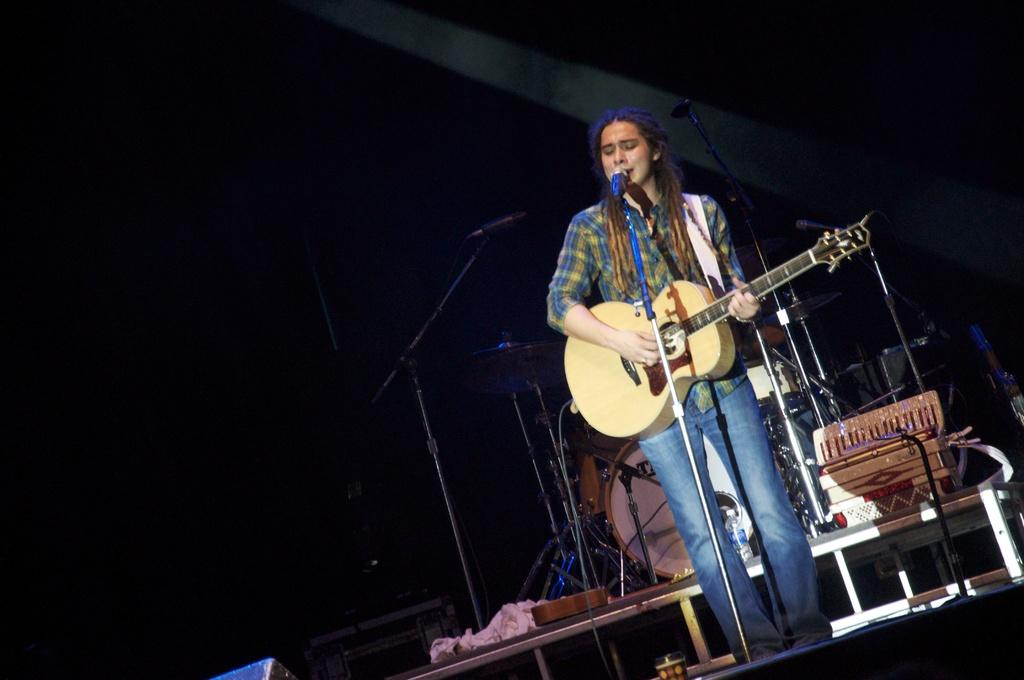Who is the main subject in the image? There is a woman in the image. What is the woman doing in the image? The woman is playing a guitar and singing. How is the woman's voice being amplified in the image? The woman is using a microphone. What type of shop can be seen in the background of the image? There is no shop present in the image; it features a woman playing a guitar, singing, and using a microphone. 